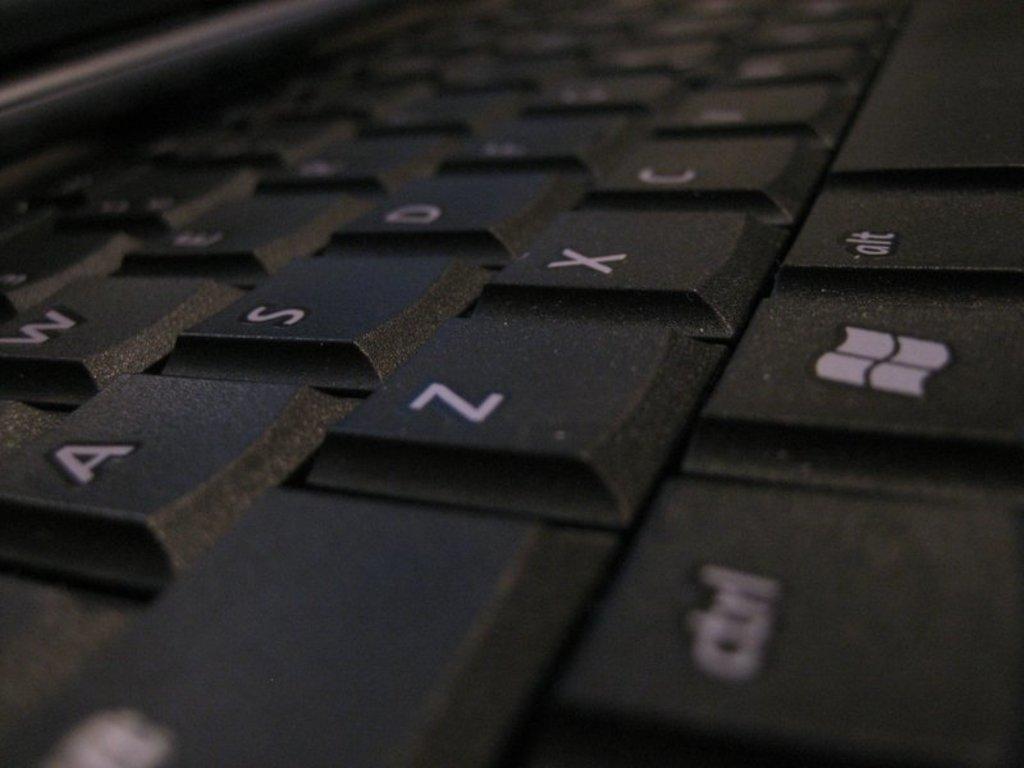What three letters are on the key above the window key?
Give a very brief answer. Zxc. 